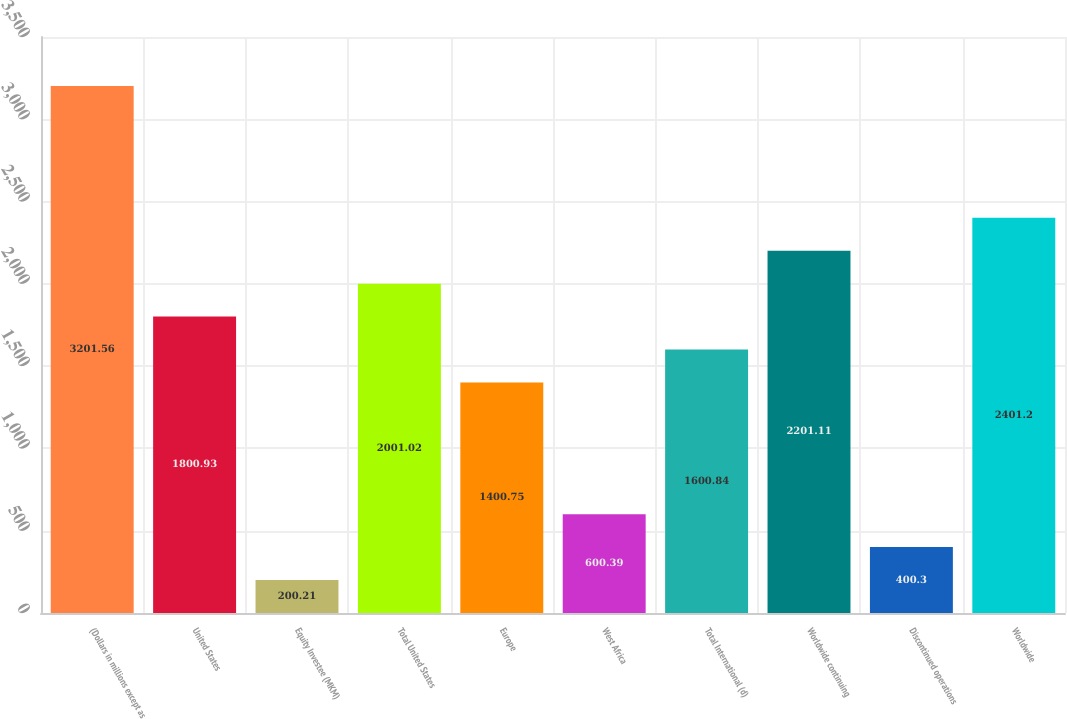Convert chart. <chart><loc_0><loc_0><loc_500><loc_500><bar_chart><fcel>(Dollars in millions except as<fcel>United States<fcel>Equity Investee (MKM)<fcel>Total United States<fcel>Europe<fcel>West Africa<fcel>Total International (d)<fcel>Worldwide continuing<fcel>Discontinued operations<fcel>Worldwide<nl><fcel>3201.56<fcel>1800.93<fcel>200.21<fcel>2001.02<fcel>1400.75<fcel>600.39<fcel>1600.84<fcel>2201.11<fcel>400.3<fcel>2401.2<nl></chart> 